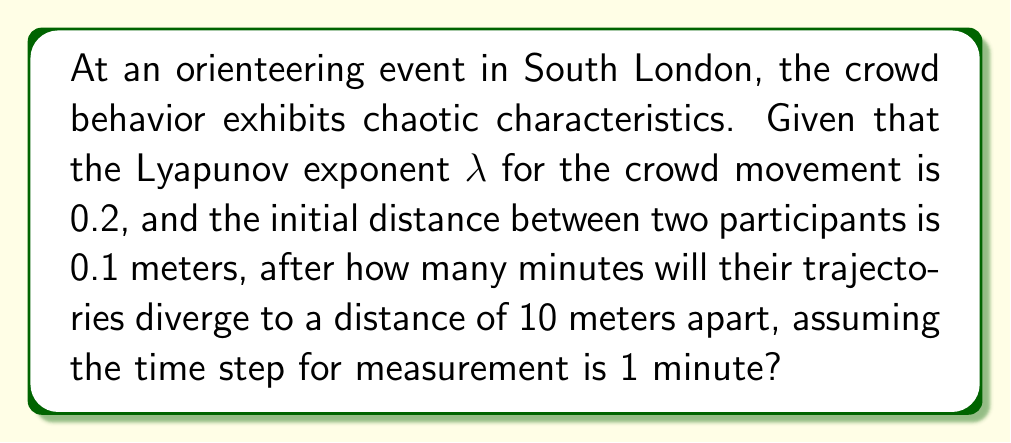Give your solution to this math problem. To solve this problem, we'll use the principles of chaos theory, specifically the concept of the Lyapunov exponent. The Lyapunov exponent measures the rate of separation of infinitesimally close trajectories in a dynamical system.

Step 1: Identify the given information
- Lyapunov exponent (λ) = 0.2
- Initial distance (d₀) = 0.1 meters
- Final distance (d) = 10 meters
- Time step (Δt) = 1 minute

Step 2: Recall the formula for trajectory divergence in chaotic systems
The distance between two initially close trajectories can be approximated by:

$$ d(t) = d_0 e^{\lambda t} $$

Where:
- d(t) is the distance at time t
- d₀ is the initial distance
- λ is the Lyapunov exponent
- t is the time

Step 3: Substitute the known values and solve for t
$$ 10 = 0.1 e^{0.2t} $$

Step 4: Take the natural logarithm of both sides
$$ \ln(10) = \ln(0.1 e^{0.2t}) $$
$$ \ln(10) = \ln(0.1) + 0.2t $$

Step 5: Solve for t
$$ 0.2t = \ln(10) - \ln(0.1) $$
$$ 0.2t = \ln(100) $$
$$ 0.2t = 4.60517 $$
$$ t = \frac{4.60517}{0.2} $$
$$ t \approx 23.02585 $$

Step 6: Round to the nearest minute
t ≈ 23 minutes
Answer: 23 minutes 